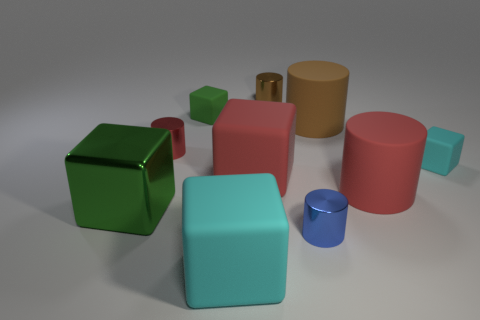The small rubber object that is on the left side of the tiny cylinder that is behind the tiny rubber thing to the left of the small blue cylinder is what shape?
Give a very brief answer. Cube. What is the material of the large cyan thing that is the same shape as the large green shiny thing?
Provide a short and direct response. Rubber. How many big yellow rubber cylinders are there?
Provide a short and direct response. 0. What shape is the tiny brown thing behind the large metallic object?
Provide a succinct answer. Cylinder. There is a large object that is behind the red metal object left of the small cylinder that is in front of the large red cube; what color is it?
Make the answer very short. Brown. There is another cyan object that is made of the same material as the tiny cyan object; what is its shape?
Offer a very short reply. Cube. Is the number of brown cylinders less than the number of tiny purple spheres?
Provide a succinct answer. No. Is the material of the large brown thing the same as the blue thing?
Ensure brevity in your answer.  No. What number of other things are there of the same color as the large shiny object?
Keep it short and to the point. 1. Are there more green matte cylinders than cyan rubber things?
Your answer should be very brief. No. 